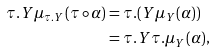<formula> <loc_0><loc_0><loc_500><loc_500>\tau . Y \mu _ { \tau . Y } ( \tau \circ \alpha ) & = \tau . ( Y \mu _ { Y } ( \alpha ) ) \\ & = \tau . Y \tau . \mu _ { Y } ( \alpha ) \text {,}</formula> 